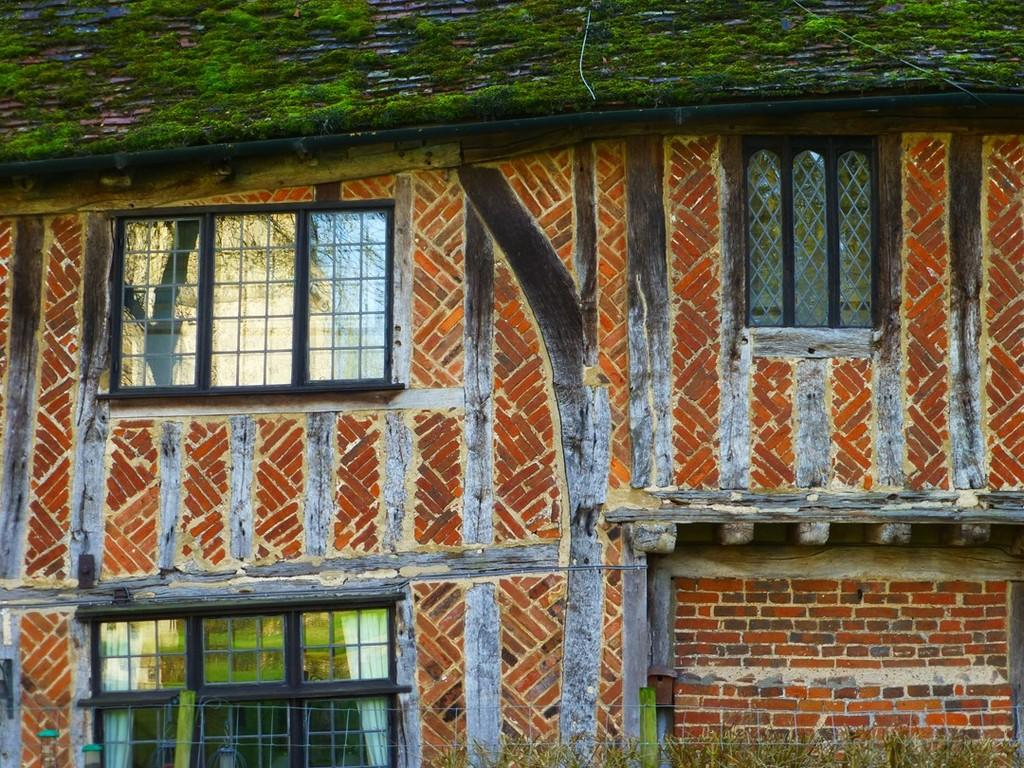What type of structure is present in the image? There is a building in the image. What feature can be seen on the building? The building has windows. What is an unusual characteristic of the building? There is grass on the roof of the building. What type of record can be seen spinning on the sidewalk in the image? There is no record or sidewalk present in the image; it only features a building with grass on the roof. 